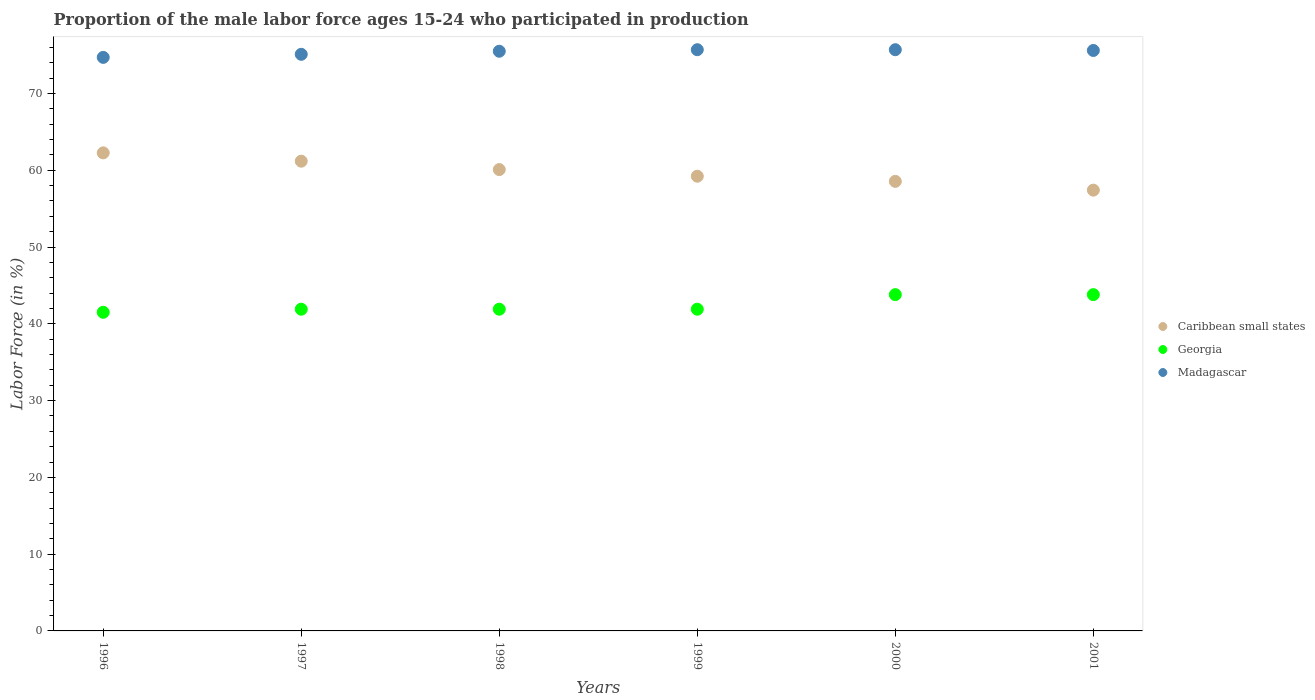What is the proportion of the male labor force who participated in production in Georgia in 2000?
Provide a short and direct response. 43.8. Across all years, what is the maximum proportion of the male labor force who participated in production in Georgia?
Offer a terse response. 43.8. Across all years, what is the minimum proportion of the male labor force who participated in production in Caribbean small states?
Keep it short and to the point. 57.41. In which year was the proportion of the male labor force who participated in production in Georgia maximum?
Provide a succinct answer. 2000. In which year was the proportion of the male labor force who participated in production in Madagascar minimum?
Provide a short and direct response. 1996. What is the total proportion of the male labor force who participated in production in Georgia in the graph?
Your answer should be compact. 254.8. What is the difference between the proportion of the male labor force who participated in production in Georgia in 1997 and that in 2001?
Offer a very short reply. -1.9. What is the difference between the proportion of the male labor force who participated in production in Caribbean small states in 1997 and the proportion of the male labor force who participated in production in Georgia in 2001?
Your answer should be very brief. 17.38. What is the average proportion of the male labor force who participated in production in Caribbean small states per year?
Offer a terse response. 59.79. In the year 1996, what is the difference between the proportion of the male labor force who participated in production in Caribbean small states and proportion of the male labor force who participated in production in Madagascar?
Your answer should be very brief. -12.43. What is the ratio of the proportion of the male labor force who participated in production in Caribbean small states in 1999 to that in 2001?
Provide a short and direct response. 1.03. Is the difference between the proportion of the male labor force who participated in production in Caribbean small states in 1997 and 2001 greater than the difference between the proportion of the male labor force who participated in production in Madagascar in 1997 and 2001?
Ensure brevity in your answer.  Yes. What is the difference between the highest and the second highest proportion of the male labor force who participated in production in Caribbean small states?
Give a very brief answer. 1.08. What is the difference between the highest and the lowest proportion of the male labor force who participated in production in Georgia?
Your response must be concise. 2.3. In how many years, is the proportion of the male labor force who participated in production in Georgia greater than the average proportion of the male labor force who participated in production in Georgia taken over all years?
Make the answer very short. 2. Is the sum of the proportion of the male labor force who participated in production in Georgia in 1998 and 1999 greater than the maximum proportion of the male labor force who participated in production in Madagascar across all years?
Offer a terse response. Yes. Does the proportion of the male labor force who participated in production in Georgia monotonically increase over the years?
Give a very brief answer. No. How many dotlines are there?
Your answer should be very brief. 3. How many years are there in the graph?
Your answer should be compact. 6. What is the difference between two consecutive major ticks on the Y-axis?
Offer a terse response. 10. Are the values on the major ticks of Y-axis written in scientific E-notation?
Ensure brevity in your answer.  No. Does the graph contain grids?
Offer a very short reply. No. What is the title of the graph?
Offer a very short reply. Proportion of the male labor force ages 15-24 who participated in production. Does "Burkina Faso" appear as one of the legend labels in the graph?
Ensure brevity in your answer.  No. What is the Labor Force (in %) in Caribbean small states in 1996?
Provide a short and direct response. 62.27. What is the Labor Force (in %) in Georgia in 1996?
Offer a very short reply. 41.5. What is the Labor Force (in %) of Madagascar in 1996?
Your response must be concise. 74.7. What is the Labor Force (in %) in Caribbean small states in 1997?
Provide a short and direct response. 61.18. What is the Labor Force (in %) of Georgia in 1997?
Provide a short and direct response. 41.9. What is the Labor Force (in %) of Madagascar in 1997?
Provide a short and direct response. 75.1. What is the Labor Force (in %) in Caribbean small states in 1998?
Provide a short and direct response. 60.09. What is the Labor Force (in %) in Georgia in 1998?
Provide a short and direct response. 41.9. What is the Labor Force (in %) of Madagascar in 1998?
Your answer should be compact. 75.5. What is the Labor Force (in %) of Caribbean small states in 1999?
Ensure brevity in your answer.  59.22. What is the Labor Force (in %) of Georgia in 1999?
Your answer should be compact. 41.9. What is the Labor Force (in %) of Madagascar in 1999?
Make the answer very short. 75.7. What is the Labor Force (in %) of Caribbean small states in 2000?
Ensure brevity in your answer.  58.55. What is the Labor Force (in %) in Georgia in 2000?
Offer a terse response. 43.8. What is the Labor Force (in %) in Madagascar in 2000?
Make the answer very short. 75.7. What is the Labor Force (in %) of Caribbean small states in 2001?
Your answer should be compact. 57.41. What is the Labor Force (in %) of Georgia in 2001?
Ensure brevity in your answer.  43.8. What is the Labor Force (in %) in Madagascar in 2001?
Your answer should be very brief. 75.6. Across all years, what is the maximum Labor Force (in %) in Caribbean small states?
Offer a terse response. 62.27. Across all years, what is the maximum Labor Force (in %) in Georgia?
Give a very brief answer. 43.8. Across all years, what is the maximum Labor Force (in %) in Madagascar?
Ensure brevity in your answer.  75.7. Across all years, what is the minimum Labor Force (in %) in Caribbean small states?
Offer a terse response. 57.41. Across all years, what is the minimum Labor Force (in %) of Georgia?
Your answer should be compact. 41.5. Across all years, what is the minimum Labor Force (in %) of Madagascar?
Give a very brief answer. 74.7. What is the total Labor Force (in %) in Caribbean small states in the graph?
Provide a succinct answer. 358.72. What is the total Labor Force (in %) of Georgia in the graph?
Provide a succinct answer. 254.8. What is the total Labor Force (in %) in Madagascar in the graph?
Your response must be concise. 452.3. What is the difference between the Labor Force (in %) in Caribbean small states in 1996 and that in 1997?
Provide a succinct answer. 1.08. What is the difference between the Labor Force (in %) in Madagascar in 1996 and that in 1997?
Offer a terse response. -0.4. What is the difference between the Labor Force (in %) of Caribbean small states in 1996 and that in 1998?
Provide a short and direct response. 2.18. What is the difference between the Labor Force (in %) of Caribbean small states in 1996 and that in 1999?
Offer a terse response. 3.04. What is the difference between the Labor Force (in %) of Georgia in 1996 and that in 1999?
Ensure brevity in your answer.  -0.4. What is the difference between the Labor Force (in %) in Caribbean small states in 1996 and that in 2000?
Provide a succinct answer. 3.71. What is the difference between the Labor Force (in %) of Georgia in 1996 and that in 2000?
Your answer should be compact. -2.3. What is the difference between the Labor Force (in %) in Caribbean small states in 1996 and that in 2001?
Your answer should be compact. 4.86. What is the difference between the Labor Force (in %) in Georgia in 1996 and that in 2001?
Provide a short and direct response. -2.3. What is the difference between the Labor Force (in %) of Caribbean small states in 1997 and that in 1998?
Make the answer very short. 1.09. What is the difference between the Labor Force (in %) of Caribbean small states in 1997 and that in 1999?
Your answer should be compact. 1.96. What is the difference between the Labor Force (in %) in Caribbean small states in 1997 and that in 2000?
Offer a terse response. 2.63. What is the difference between the Labor Force (in %) of Georgia in 1997 and that in 2000?
Your answer should be very brief. -1.9. What is the difference between the Labor Force (in %) in Caribbean small states in 1997 and that in 2001?
Your answer should be compact. 3.77. What is the difference between the Labor Force (in %) in Georgia in 1997 and that in 2001?
Your answer should be very brief. -1.9. What is the difference between the Labor Force (in %) in Caribbean small states in 1998 and that in 1999?
Your response must be concise. 0.87. What is the difference between the Labor Force (in %) of Caribbean small states in 1998 and that in 2000?
Give a very brief answer. 1.53. What is the difference between the Labor Force (in %) of Madagascar in 1998 and that in 2000?
Make the answer very short. -0.2. What is the difference between the Labor Force (in %) of Caribbean small states in 1998 and that in 2001?
Your answer should be compact. 2.68. What is the difference between the Labor Force (in %) of Madagascar in 1998 and that in 2001?
Give a very brief answer. -0.1. What is the difference between the Labor Force (in %) of Caribbean small states in 1999 and that in 2000?
Provide a succinct answer. 0.67. What is the difference between the Labor Force (in %) of Georgia in 1999 and that in 2000?
Your answer should be compact. -1.9. What is the difference between the Labor Force (in %) in Caribbean small states in 1999 and that in 2001?
Ensure brevity in your answer.  1.81. What is the difference between the Labor Force (in %) in Caribbean small states in 2000 and that in 2001?
Provide a short and direct response. 1.14. What is the difference between the Labor Force (in %) of Georgia in 2000 and that in 2001?
Provide a short and direct response. 0. What is the difference between the Labor Force (in %) in Caribbean small states in 1996 and the Labor Force (in %) in Georgia in 1997?
Ensure brevity in your answer.  20.37. What is the difference between the Labor Force (in %) of Caribbean small states in 1996 and the Labor Force (in %) of Madagascar in 1997?
Ensure brevity in your answer.  -12.83. What is the difference between the Labor Force (in %) in Georgia in 1996 and the Labor Force (in %) in Madagascar in 1997?
Your response must be concise. -33.6. What is the difference between the Labor Force (in %) in Caribbean small states in 1996 and the Labor Force (in %) in Georgia in 1998?
Your answer should be compact. 20.37. What is the difference between the Labor Force (in %) in Caribbean small states in 1996 and the Labor Force (in %) in Madagascar in 1998?
Offer a very short reply. -13.23. What is the difference between the Labor Force (in %) in Georgia in 1996 and the Labor Force (in %) in Madagascar in 1998?
Offer a very short reply. -34. What is the difference between the Labor Force (in %) of Caribbean small states in 1996 and the Labor Force (in %) of Georgia in 1999?
Provide a short and direct response. 20.37. What is the difference between the Labor Force (in %) in Caribbean small states in 1996 and the Labor Force (in %) in Madagascar in 1999?
Provide a short and direct response. -13.43. What is the difference between the Labor Force (in %) in Georgia in 1996 and the Labor Force (in %) in Madagascar in 1999?
Your response must be concise. -34.2. What is the difference between the Labor Force (in %) in Caribbean small states in 1996 and the Labor Force (in %) in Georgia in 2000?
Your answer should be compact. 18.47. What is the difference between the Labor Force (in %) of Caribbean small states in 1996 and the Labor Force (in %) of Madagascar in 2000?
Offer a very short reply. -13.43. What is the difference between the Labor Force (in %) in Georgia in 1996 and the Labor Force (in %) in Madagascar in 2000?
Your response must be concise. -34.2. What is the difference between the Labor Force (in %) of Caribbean small states in 1996 and the Labor Force (in %) of Georgia in 2001?
Your answer should be very brief. 18.47. What is the difference between the Labor Force (in %) of Caribbean small states in 1996 and the Labor Force (in %) of Madagascar in 2001?
Provide a succinct answer. -13.33. What is the difference between the Labor Force (in %) in Georgia in 1996 and the Labor Force (in %) in Madagascar in 2001?
Offer a terse response. -34.1. What is the difference between the Labor Force (in %) in Caribbean small states in 1997 and the Labor Force (in %) in Georgia in 1998?
Provide a short and direct response. 19.28. What is the difference between the Labor Force (in %) in Caribbean small states in 1997 and the Labor Force (in %) in Madagascar in 1998?
Give a very brief answer. -14.32. What is the difference between the Labor Force (in %) in Georgia in 1997 and the Labor Force (in %) in Madagascar in 1998?
Offer a terse response. -33.6. What is the difference between the Labor Force (in %) in Caribbean small states in 1997 and the Labor Force (in %) in Georgia in 1999?
Your answer should be very brief. 19.28. What is the difference between the Labor Force (in %) of Caribbean small states in 1997 and the Labor Force (in %) of Madagascar in 1999?
Ensure brevity in your answer.  -14.52. What is the difference between the Labor Force (in %) of Georgia in 1997 and the Labor Force (in %) of Madagascar in 1999?
Your response must be concise. -33.8. What is the difference between the Labor Force (in %) of Caribbean small states in 1997 and the Labor Force (in %) of Georgia in 2000?
Keep it short and to the point. 17.38. What is the difference between the Labor Force (in %) in Caribbean small states in 1997 and the Labor Force (in %) in Madagascar in 2000?
Provide a succinct answer. -14.52. What is the difference between the Labor Force (in %) of Georgia in 1997 and the Labor Force (in %) of Madagascar in 2000?
Your response must be concise. -33.8. What is the difference between the Labor Force (in %) of Caribbean small states in 1997 and the Labor Force (in %) of Georgia in 2001?
Give a very brief answer. 17.38. What is the difference between the Labor Force (in %) in Caribbean small states in 1997 and the Labor Force (in %) in Madagascar in 2001?
Provide a succinct answer. -14.42. What is the difference between the Labor Force (in %) of Georgia in 1997 and the Labor Force (in %) of Madagascar in 2001?
Make the answer very short. -33.7. What is the difference between the Labor Force (in %) in Caribbean small states in 1998 and the Labor Force (in %) in Georgia in 1999?
Provide a short and direct response. 18.19. What is the difference between the Labor Force (in %) of Caribbean small states in 1998 and the Labor Force (in %) of Madagascar in 1999?
Your answer should be very brief. -15.61. What is the difference between the Labor Force (in %) of Georgia in 1998 and the Labor Force (in %) of Madagascar in 1999?
Your response must be concise. -33.8. What is the difference between the Labor Force (in %) of Caribbean small states in 1998 and the Labor Force (in %) of Georgia in 2000?
Keep it short and to the point. 16.29. What is the difference between the Labor Force (in %) of Caribbean small states in 1998 and the Labor Force (in %) of Madagascar in 2000?
Offer a terse response. -15.61. What is the difference between the Labor Force (in %) of Georgia in 1998 and the Labor Force (in %) of Madagascar in 2000?
Offer a very short reply. -33.8. What is the difference between the Labor Force (in %) of Caribbean small states in 1998 and the Labor Force (in %) of Georgia in 2001?
Offer a very short reply. 16.29. What is the difference between the Labor Force (in %) of Caribbean small states in 1998 and the Labor Force (in %) of Madagascar in 2001?
Provide a short and direct response. -15.51. What is the difference between the Labor Force (in %) of Georgia in 1998 and the Labor Force (in %) of Madagascar in 2001?
Provide a succinct answer. -33.7. What is the difference between the Labor Force (in %) in Caribbean small states in 1999 and the Labor Force (in %) in Georgia in 2000?
Your answer should be compact. 15.42. What is the difference between the Labor Force (in %) in Caribbean small states in 1999 and the Labor Force (in %) in Madagascar in 2000?
Provide a succinct answer. -16.48. What is the difference between the Labor Force (in %) of Georgia in 1999 and the Labor Force (in %) of Madagascar in 2000?
Give a very brief answer. -33.8. What is the difference between the Labor Force (in %) in Caribbean small states in 1999 and the Labor Force (in %) in Georgia in 2001?
Offer a very short reply. 15.42. What is the difference between the Labor Force (in %) in Caribbean small states in 1999 and the Labor Force (in %) in Madagascar in 2001?
Give a very brief answer. -16.38. What is the difference between the Labor Force (in %) of Georgia in 1999 and the Labor Force (in %) of Madagascar in 2001?
Provide a succinct answer. -33.7. What is the difference between the Labor Force (in %) of Caribbean small states in 2000 and the Labor Force (in %) of Georgia in 2001?
Give a very brief answer. 14.75. What is the difference between the Labor Force (in %) in Caribbean small states in 2000 and the Labor Force (in %) in Madagascar in 2001?
Keep it short and to the point. -17.05. What is the difference between the Labor Force (in %) in Georgia in 2000 and the Labor Force (in %) in Madagascar in 2001?
Your answer should be very brief. -31.8. What is the average Labor Force (in %) of Caribbean small states per year?
Make the answer very short. 59.79. What is the average Labor Force (in %) of Georgia per year?
Offer a terse response. 42.47. What is the average Labor Force (in %) in Madagascar per year?
Your answer should be compact. 75.38. In the year 1996, what is the difference between the Labor Force (in %) in Caribbean small states and Labor Force (in %) in Georgia?
Ensure brevity in your answer.  20.77. In the year 1996, what is the difference between the Labor Force (in %) in Caribbean small states and Labor Force (in %) in Madagascar?
Your response must be concise. -12.43. In the year 1996, what is the difference between the Labor Force (in %) in Georgia and Labor Force (in %) in Madagascar?
Give a very brief answer. -33.2. In the year 1997, what is the difference between the Labor Force (in %) in Caribbean small states and Labor Force (in %) in Georgia?
Offer a terse response. 19.28. In the year 1997, what is the difference between the Labor Force (in %) in Caribbean small states and Labor Force (in %) in Madagascar?
Provide a short and direct response. -13.92. In the year 1997, what is the difference between the Labor Force (in %) of Georgia and Labor Force (in %) of Madagascar?
Your answer should be compact. -33.2. In the year 1998, what is the difference between the Labor Force (in %) in Caribbean small states and Labor Force (in %) in Georgia?
Your response must be concise. 18.19. In the year 1998, what is the difference between the Labor Force (in %) in Caribbean small states and Labor Force (in %) in Madagascar?
Offer a terse response. -15.41. In the year 1998, what is the difference between the Labor Force (in %) of Georgia and Labor Force (in %) of Madagascar?
Make the answer very short. -33.6. In the year 1999, what is the difference between the Labor Force (in %) of Caribbean small states and Labor Force (in %) of Georgia?
Offer a terse response. 17.32. In the year 1999, what is the difference between the Labor Force (in %) in Caribbean small states and Labor Force (in %) in Madagascar?
Offer a terse response. -16.48. In the year 1999, what is the difference between the Labor Force (in %) in Georgia and Labor Force (in %) in Madagascar?
Offer a terse response. -33.8. In the year 2000, what is the difference between the Labor Force (in %) in Caribbean small states and Labor Force (in %) in Georgia?
Your response must be concise. 14.75. In the year 2000, what is the difference between the Labor Force (in %) of Caribbean small states and Labor Force (in %) of Madagascar?
Keep it short and to the point. -17.15. In the year 2000, what is the difference between the Labor Force (in %) of Georgia and Labor Force (in %) of Madagascar?
Your answer should be compact. -31.9. In the year 2001, what is the difference between the Labor Force (in %) of Caribbean small states and Labor Force (in %) of Georgia?
Your answer should be very brief. 13.61. In the year 2001, what is the difference between the Labor Force (in %) of Caribbean small states and Labor Force (in %) of Madagascar?
Make the answer very short. -18.19. In the year 2001, what is the difference between the Labor Force (in %) in Georgia and Labor Force (in %) in Madagascar?
Offer a very short reply. -31.8. What is the ratio of the Labor Force (in %) in Caribbean small states in 1996 to that in 1997?
Your answer should be very brief. 1.02. What is the ratio of the Labor Force (in %) in Georgia in 1996 to that in 1997?
Keep it short and to the point. 0.99. What is the ratio of the Labor Force (in %) of Caribbean small states in 1996 to that in 1998?
Make the answer very short. 1.04. What is the ratio of the Labor Force (in %) of Caribbean small states in 1996 to that in 1999?
Provide a succinct answer. 1.05. What is the ratio of the Labor Force (in %) of Madagascar in 1996 to that in 1999?
Your answer should be very brief. 0.99. What is the ratio of the Labor Force (in %) in Caribbean small states in 1996 to that in 2000?
Offer a very short reply. 1.06. What is the ratio of the Labor Force (in %) of Georgia in 1996 to that in 2000?
Provide a succinct answer. 0.95. What is the ratio of the Labor Force (in %) in Madagascar in 1996 to that in 2000?
Your answer should be compact. 0.99. What is the ratio of the Labor Force (in %) of Caribbean small states in 1996 to that in 2001?
Offer a very short reply. 1.08. What is the ratio of the Labor Force (in %) in Georgia in 1996 to that in 2001?
Offer a terse response. 0.95. What is the ratio of the Labor Force (in %) in Madagascar in 1996 to that in 2001?
Give a very brief answer. 0.99. What is the ratio of the Labor Force (in %) in Caribbean small states in 1997 to that in 1998?
Offer a very short reply. 1.02. What is the ratio of the Labor Force (in %) of Caribbean small states in 1997 to that in 1999?
Your answer should be very brief. 1.03. What is the ratio of the Labor Force (in %) in Georgia in 1997 to that in 1999?
Ensure brevity in your answer.  1. What is the ratio of the Labor Force (in %) of Caribbean small states in 1997 to that in 2000?
Ensure brevity in your answer.  1.04. What is the ratio of the Labor Force (in %) in Georgia in 1997 to that in 2000?
Offer a terse response. 0.96. What is the ratio of the Labor Force (in %) in Madagascar in 1997 to that in 2000?
Keep it short and to the point. 0.99. What is the ratio of the Labor Force (in %) in Caribbean small states in 1997 to that in 2001?
Your answer should be very brief. 1.07. What is the ratio of the Labor Force (in %) of Georgia in 1997 to that in 2001?
Keep it short and to the point. 0.96. What is the ratio of the Labor Force (in %) in Madagascar in 1997 to that in 2001?
Ensure brevity in your answer.  0.99. What is the ratio of the Labor Force (in %) in Caribbean small states in 1998 to that in 1999?
Offer a very short reply. 1.01. What is the ratio of the Labor Force (in %) in Georgia in 1998 to that in 1999?
Keep it short and to the point. 1. What is the ratio of the Labor Force (in %) in Caribbean small states in 1998 to that in 2000?
Provide a succinct answer. 1.03. What is the ratio of the Labor Force (in %) in Georgia in 1998 to that in 2000?
Make the answer very short. 0.96. What is the ratio of the Labor Force (in %) of Caribbean small states in 1998 to that in 2001?
Your answer should be compact. 1.05. What is the ratio of the Labor Force (in %) in Georgia in 1998 to that in 2001?
Your response must be concise. 0.96. What is the ratio of the Labor Force (in %) in Caribbean small states in 1999 to that in 2000?
Your response must be concise. 1.01. What is the ratio of the Labor Force (in %) in Georgia in 1999 to that in 2000?
Offer a terse response. 0.96. What is the ratio of the Labor Force (in %) of Caribbean small states in 1999 to that in 2001?
Make the answer very short. 1.03. What is the ratio of the Labor Force (in %) of Georgia in 1999 to that in 2001?
Your answer should be compact. 0.96. What is the ratio of the Labor Force (in %) in Madagascar in 1999 to that in 2001?
Offer a very short reply. 1. What is the ratio of the Labor Force (in %) in Caribbean small states in 2000 to that in 2001?
Provide a short and direct response. 1.02. What is the ratio of the Labor Force (in %) of Madagascar in 2000 to that in 2001?
Your answer should be compact. 1. What is the difference between the highest and the second highest Labor Force (in %) in Caribbean small states?
Provide a short and direct response. 1.08. What is the difference between the highest and the second highest Labor Force (in %) of Madagascar?
Give a very brief answer. 0. What is the difference between the highest and the lowest Labor Force (in %) of Caribbean small states?
Offer a very short reply. 4.86. What is the difference between the highest and the lowest Labor Force (in %) in Georgia?
Ensure brevity in your answer.  2.3. What is the difference between the highest and the lowest Labor Force (in %) of Madagascar?
Your response must be concise. 1. 